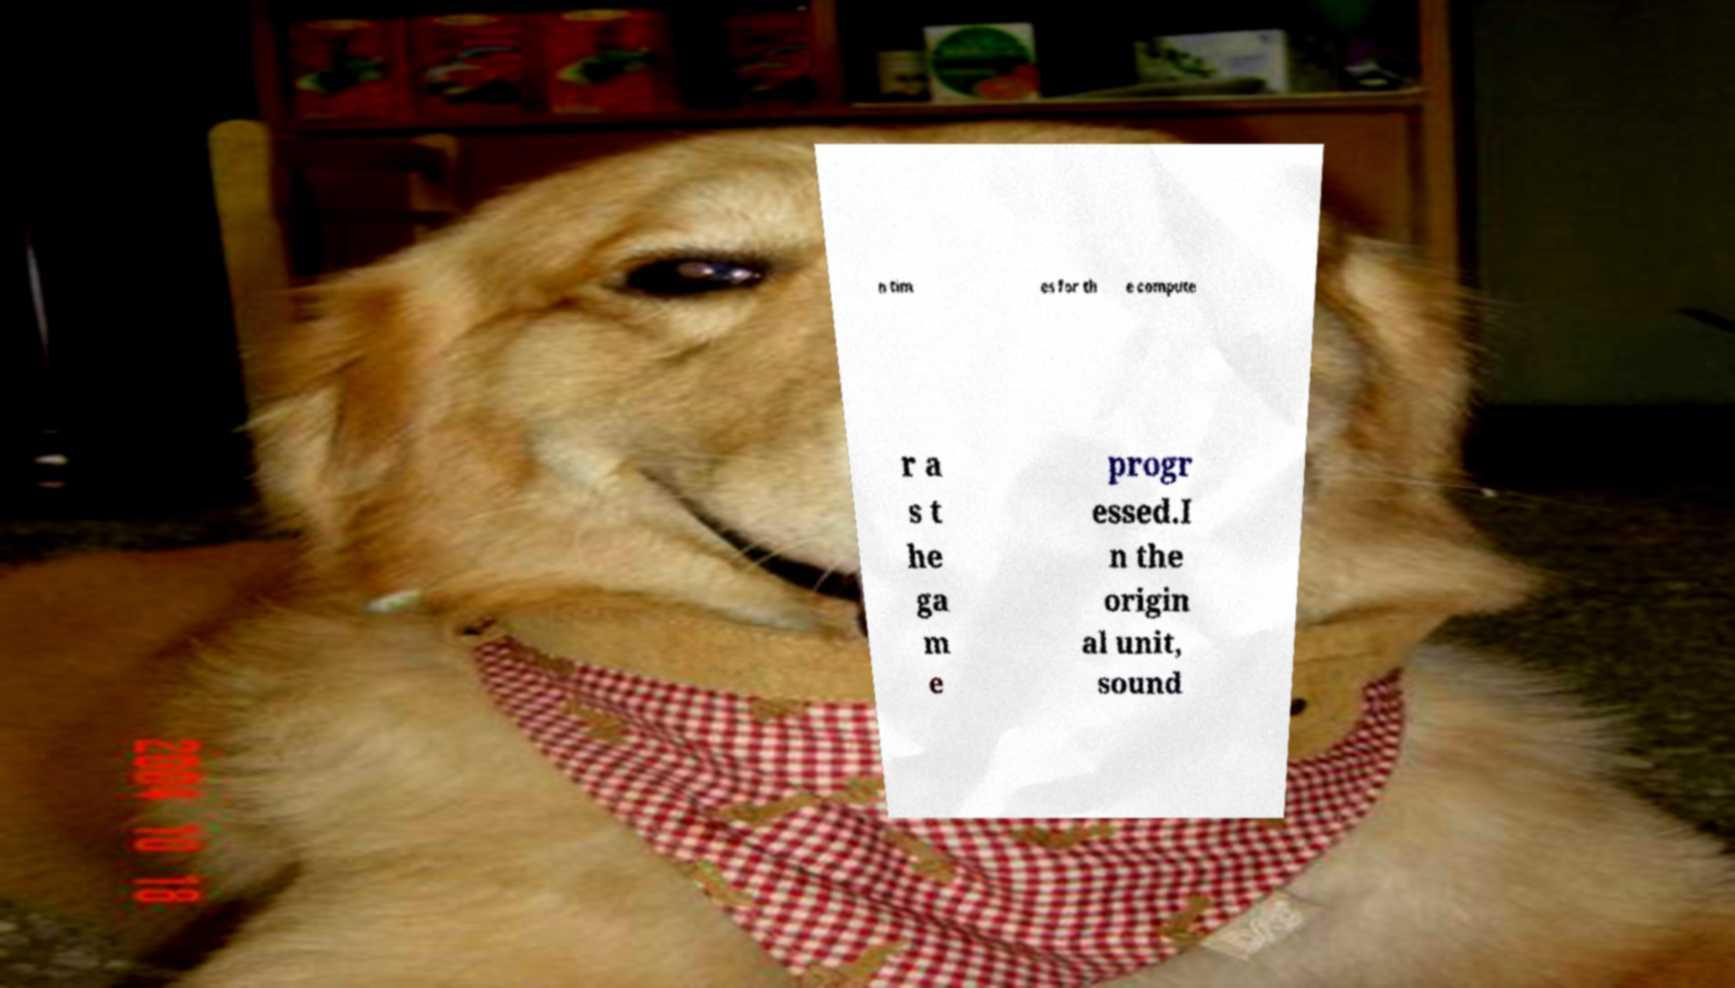For documentation purposes, I need the text within this image transcribed. Could you provide that? n tim es for th e compute r a s t he ga m e progr essed.I n the origin al unit, sound 